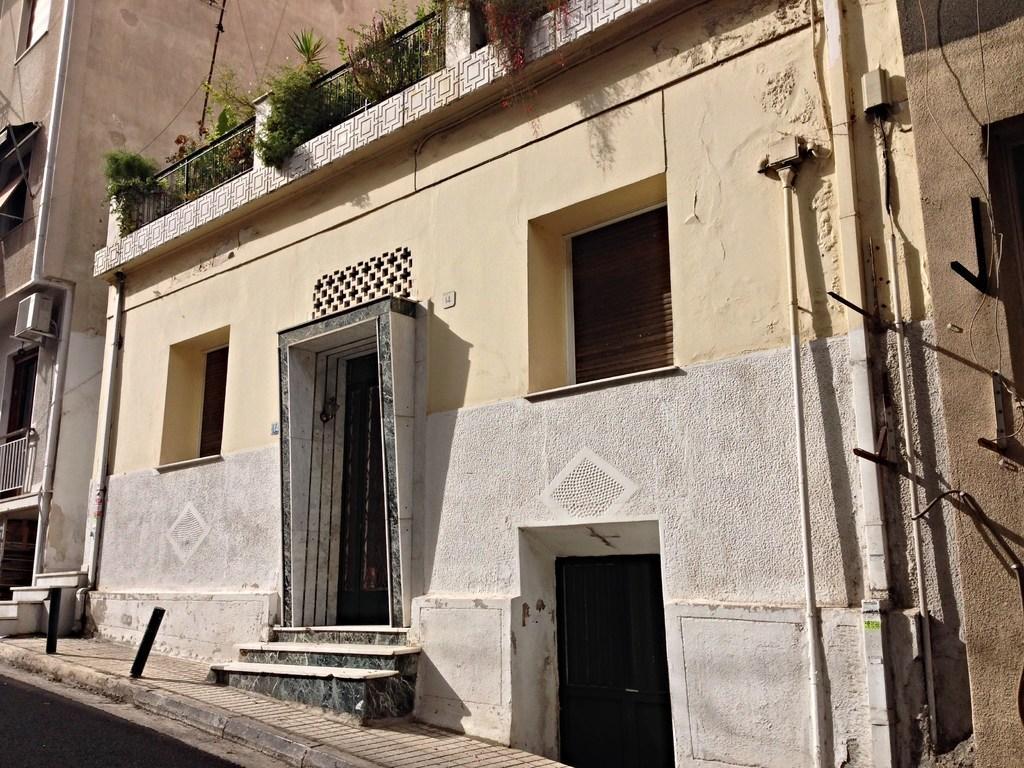Describe this image in one or two sentences. There is a road near footpath on which, there are two poles. Beside this footpath, there are buildings which are having windows and doors. There are plants on the top of the building. 